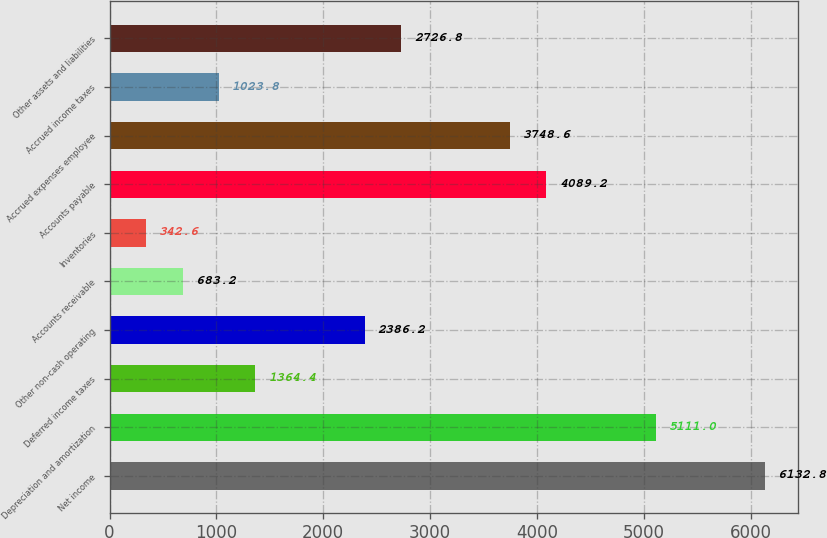Convert chart to OTSL. <chart><loc_0><loc_0><loc_500><loc_500><bar_chart><fcel>Net income<fcel>Depreciation and amortization<fcel>Deferred income taxes<fcel>Other non-cash operating<fcel>Accounts receivable<fcel>Inventories<fcel>Accounts payable<fcel>Accrued expenses employee<fcel>Accrued income taxes<fcel>Other assets and liabilities<nl><fcel>6132.8<fcel>5111<fcel>1364.4<fcel>2386.2<fcel>683.2<fcel>342.6<fcel>4089.2<fcel>3748.6<fcel>1023.8<fcel>2726.8<nl></chart> 